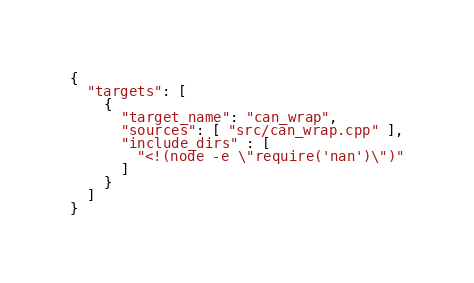<code> <loc_0><loc_0><loc_500><loc_500><_Python_>{
  "targets": [
    {
      "target_name": "can_wrap",
      "sources": [ "src/can_wrap.cpp" ],
      "include_dirs" : [
        "<!(node -e \"require('nan')\")"
      ]
    }
  ]
}
</code> 